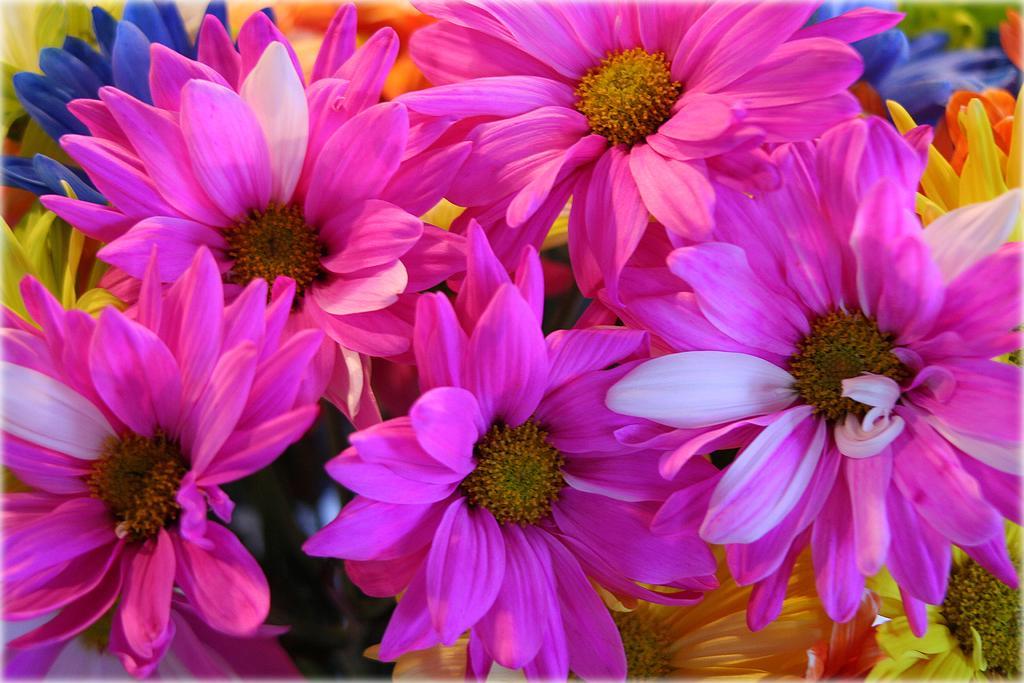Could you give a brief overview of what you see in this image? In this picture we can see a flowers are there. 